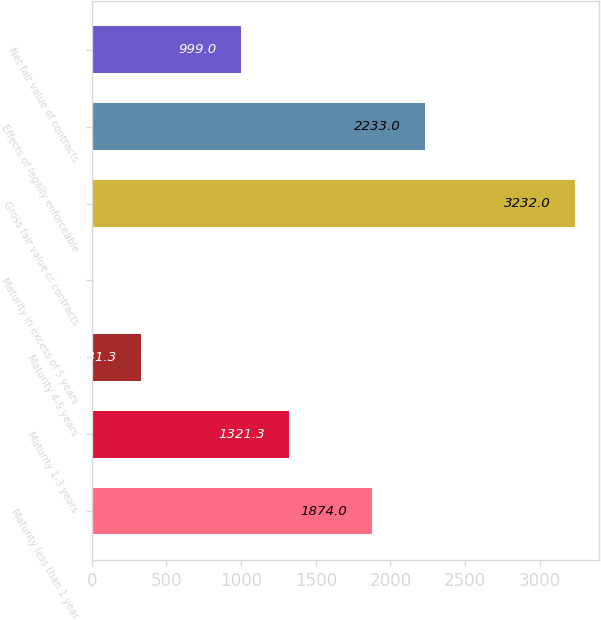Convert chart. <chart><loc_0><loc_0><loc_500><loc_500><bar_chart><fcel>Maturity less than 1 year<fcel>Maturity 1-3 years<fcel>Maturity 4-5 years<fcel>Maturity in excess of 5 years<fcel>Gross fair value of contracts<fcel>Effects of legally enforceable<fcel>Net fair value of contracts<nl><fcel>1874<fcel>1321.3<fcel>331.3<fcel>9<fcel>3232<fcel>2233<fcel>999<nl></chart> 